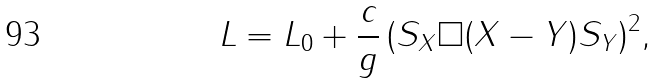Convert formula to latex. <formula><loc_0><loc_0><loc_500><loc_500>L = L _ { 0 } + \frac { c } { g } \, ( S _ { X } \Box ( X - Y ) S _ { Y } ) ^ { 2 } ,</formula> 